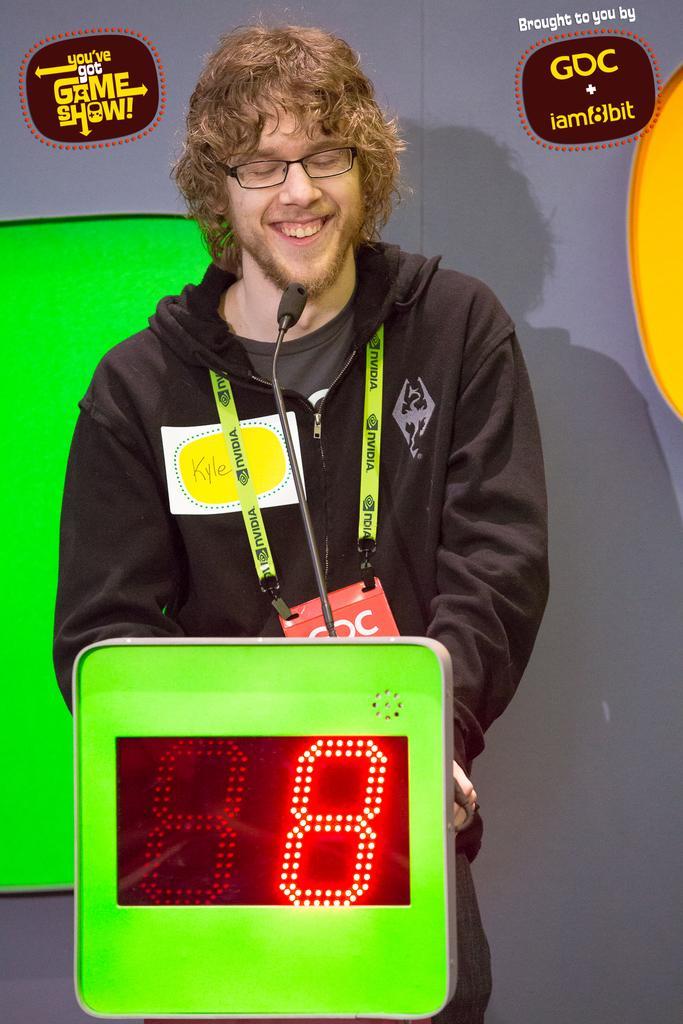In one or two sentences, can you explain what this image depicts? This is the man standing and smiling. He wore a jerkin, T-shirt, badge, spectacle and trouser. This looks like a small digital scoreboard. I can see the watermarks on the image. 